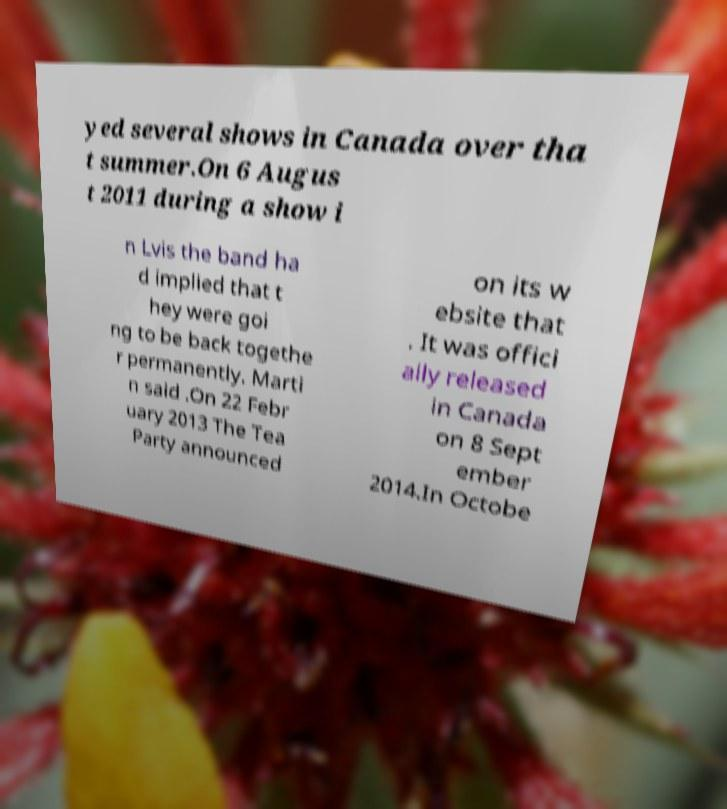Could you extract and type out the text from this image? yed several shows in Canada over tha t summer.On 6 Augus t 2011 during a show i n Lvis the band ha d implied that t hey were goi ng to be back togethe r permanently. Marti n said .On 22 Febr uary 2013 The Tea Party announced on its w ebsite that . It was offici ally released in Canada on 8 Sept ember 2014.In Octobe 